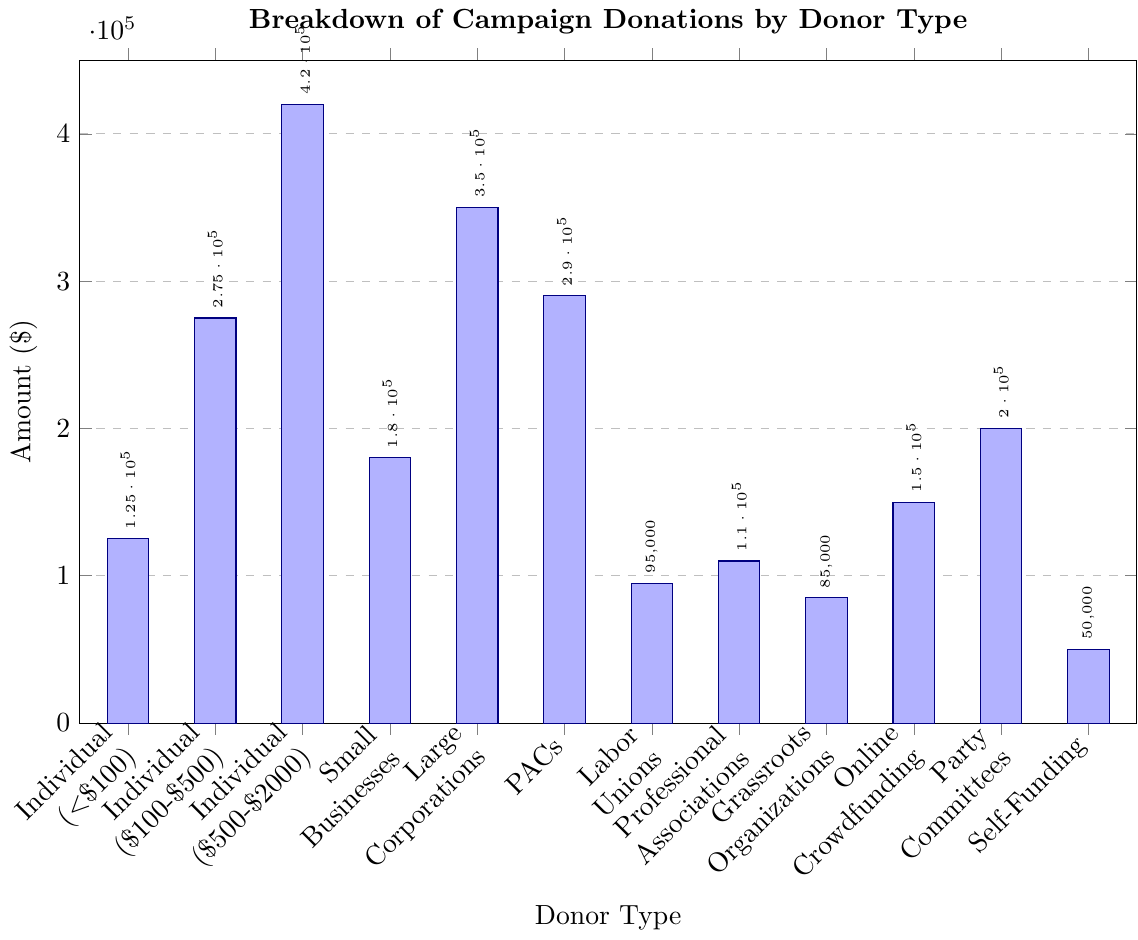What is the total amount received from all individual donors? Add the amounts from the three categories of individual donors: $125,000 + $275,000 + $420,000 = $820,000
Answer: $820,000 Which donor type contributed the most, and what is the amount? The donor type with the highest bar is 'Individual Donors ($500-$2000)' with an amount of $420,000
Answer: Individual Donors ($500-$2000), $420,000 How much more did large corporations contribute compared to small businesses? Subtract the amount from small businesses from the amount from large corporations: $350,000 - $180,000 = $170,000
Answer: $170,000 What is the average contribution amount for grassroots organizations, online crowdfunding, and party committees? Add the amounts and divide by the number of categories: ($85,000 + $150,000 + $200,000)/3 = $435,000/3 = $145,000
Answer: $145,000 Which donor type has the smallest contribution, and what is the amount? The donor type with the shortest bar is 'Self-Funding' with an amount of $50,000
Answer: Self-Funding, $50,000 Compare the contribution amounts between political action committees (PACs) and professional associations. Which is higher, and by how much? PACs contributed $290,000 and professional associations contributed $110,000. Subtract the smaller amount from the larger amount: $290,000 - $110,000 = $180,000
Answer: PACs, $180,000 What is the sum of contributions made by labor unions, professional associations, and online crowdfunding? Add the amounts: $95,000 + $110,000 + $150,000 = $355,000
Answer: $355,000 Is the contribution amount from party committees greater than that from labor unions? By how much? Party committees contributed $200,000 and labor unions contributed $95,000. Subtract the amount from labor unions from the amount from party committees: $200,000 - $95,000 = $105,000
Answer: Yes, by $105,000 What is the difference in contribution amounts between the highest and lowest donor types? The highest contribution is from 'Individual Donors ($500-$2000)' with $420,000 and the lowest is 'Self-Funding' with $50,000. Subtract the smaller amount from the larger amount: $420,000 - $50,000 = $370,000
Answer: $370,000 